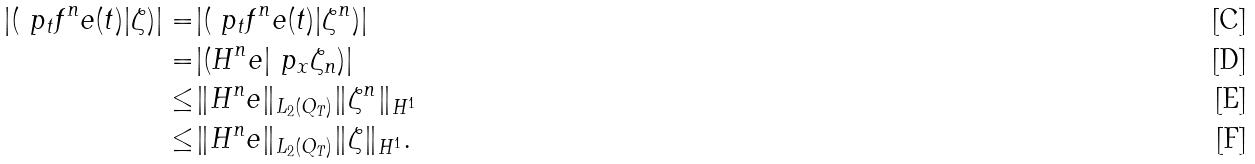<formula> <loc_0><loc_0><loc_500><loc_500>| ( \ p _ { t } f ^ { n } _ { \ } e ( t ) | \zeta ) | = & | ( \ p _ { t } f ^ { n } _ { \ } e ( t ) | \zeta ^ { n } ) | \\ = & | ( H ^ { n } _ { \ } e | \ p _ { x } \zeta _ { n } ) | \\ \leq & \| H ^ { n } _ { \ } e \| _ { L _ { 2 } ( Q _ { T } ) } \| \zeta ^ { n } \| _ { H ^ { 1 } } \\ \leq & \| H ^ { n } _ { \ } e \| _ { L _ { 2 } ( Q _ { T } ) } \| \zeta \| _ { H ^ { 1 } } .</formula> 